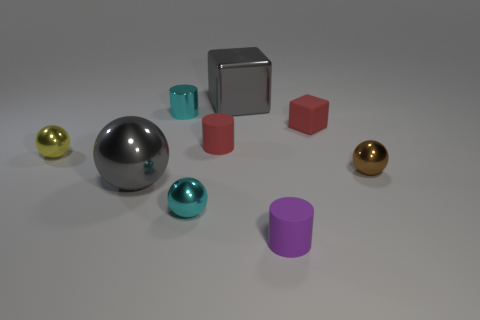Subtract all red matte cylinders. How many cylinders are left? 2 Subtract all cyan cylinders. How many cylinders are left? 2 Subtract 1 cylinders. How many cylinders are left? 2 Subtract all green balls. How many red blocks are left? 1 Subtract all rubber blocks. Subtract all tiny cyan balls. How many objects are left? 7 Add 6 big gray metallic things. How many big gray metallic things are left? 8 Add 4 small cyan metallic cylinders. How many small cyan metallic cylinders exist? 5 Subtract 0 brown blocks. How many objects are left? 9 Subtract all spheres. How many objects are left? 5 Subtract all green blocks. Subtract all blue cylinders. How many blocks are left? 2 